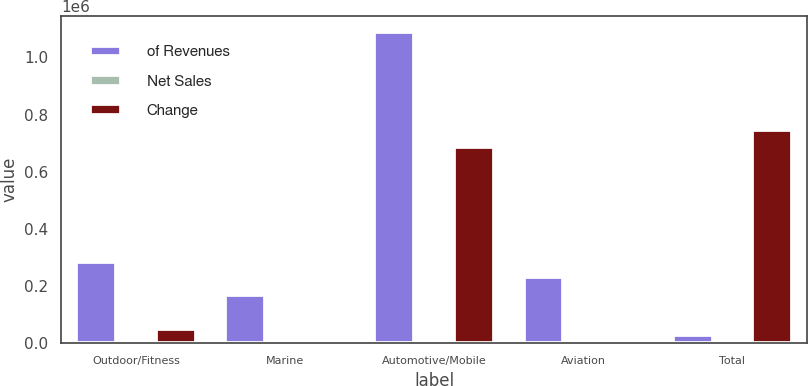Convert chart. <chart><loc_0><loc_0><loc_500><loc_500><stacked_bar_chart><ecel><fcel>Outdoor/Fitness<fcel>Marine<fcel>Automotive/Mobile<fcel>Aviation<fcel>Total<nl><fcel>of Revenues<fcel>285362<fcel>166639<fcel>1.08909e+06<fcel>232906<fcel>28401.5<nl><fcel>Net Sales<fcel>16.1<fcel>9.4<fcel>61.4<fcel>13.1<fcel>100<nl><fcel>Change<fcel>48426<fcel>8377<fcel>685676<fcel>3748<fcel>746227<nl></chart> 